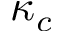<formula> <loc_0><loc_0><loc_500><loc_500>\kappa _ { c }</formula> 